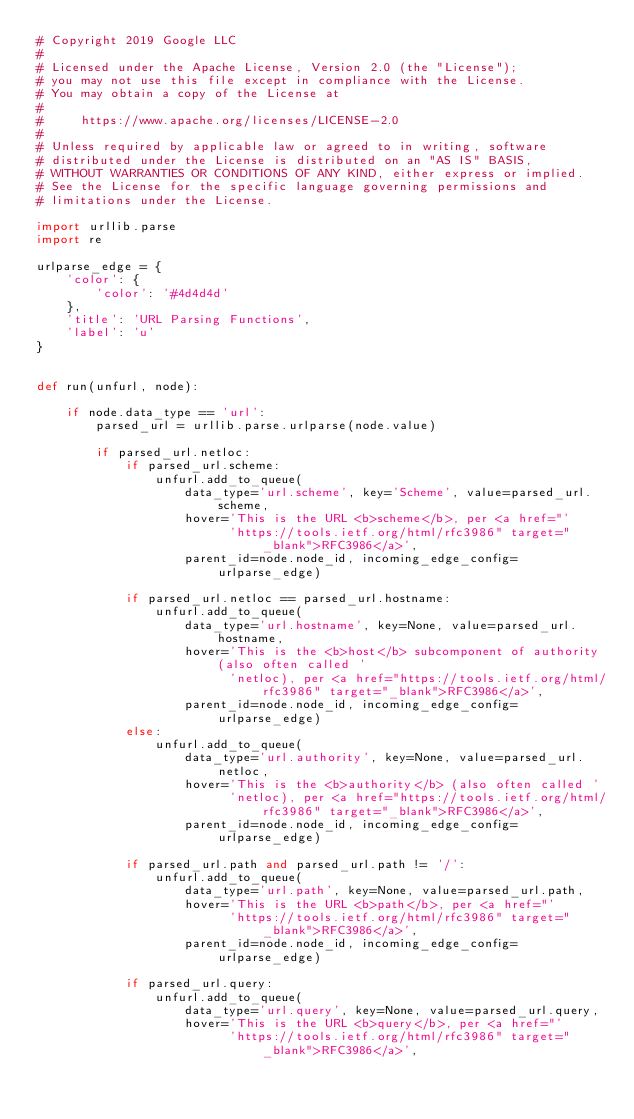Convert code to text. <code><loc_0><loc_0><loc_500><loc_500><_Python_># Copyright 2019 Google LLC
#
# Licensed under the Apache License, Version 2.0 (the "License");
# you may not use this file except in compliance with the License.
# You may obtain a copy of the License at
#
#     https://www.apache.org/licenses/LICENSE-2.0
#
# Unless required by applicable law or agreed to in writing, software
# distributed under the License is distributed on an "AS IS" BASIS,
# WITHOUT WARRANTIES OR CONDITIONS OF ANY KIND, either express or implied.
# See the License for the specific language governing permissions and
# limitations under the License.

import urllib.parse
import re

urlparse_edge = {
    'color': {
        'color': '#4d4d4d'
    },
    'title': 'URL Parsing Functions',
    'label': 'u'
}


def run(unfurl, node):

    if node.data_type == 'url':
        parsed_url = urllib.parse.urlparse(node.value)

        if parsed_url.netloc:
            if parsed_url.scheme:
                unfurl.add_to_queue(
                    data_type='url.scheme', key='Scheme', value=parsed_url.scheme,
                    hover='This is the URL <b>scheme</b>, per <a href="'
                          'https://tools.ietf.org/html/rfc3986" target="_blank">RFC3986</a>',
                    parent_id=node.node_id, incoming_edge_config=urlparse_edge)

            if parsed_url.netloc == parsed_url.hostname:
                unfurl.add_to_queue(
                    data_type='url.hostname', key=None, value=parsed_url.hostname,
                    hover='This is the <b>host</b> subcomponent of authority (also often called '
                          'netloc), per <a href="https://tools.ietf.org/html/rfc3986" target="_blank">RFC3986</a>',
                    parent_id=node.node_id, incoming_edge_config=urlparse_edge)
            else:
                unfurl.add_to_queue(
                    data_type='url.authority', key=None, value=parsed_url.netloc,
                    hover='This is the <b>authority</b> (also often called '
                          'netloc), per <a href="https://tools.ietf.org/html/rfc3986" target="_blank">RFC3986</a>',
                    parent_id=node.node_id, incoming_edge_config=urlparse_edge)

            if parsed_url.path and parsed_url.path != '/':
                unfurl.add_to_queue(
                    data_type='url.path', key=None, value=parsed_url.path,
                    hover='This is the URL <b>path</b>, per <a href="'
                          'https://tools.ietf.org/html/rfc3986" target="_blank">RFC3986</a>',
                    parent_id=node.node_id, incoming_edge_config=urlparse_edge)

            if parsed_url.query:
                unfurl.add_to_queue(
                    data_type='url.query', key=None, value=parsed_url.query,
                    hover='This is the URL <b>query</b>, per <a href="'
                          'https://tools.ietf.org/html/rfc3986" target="_blank">RFC3986</a>',</code> 